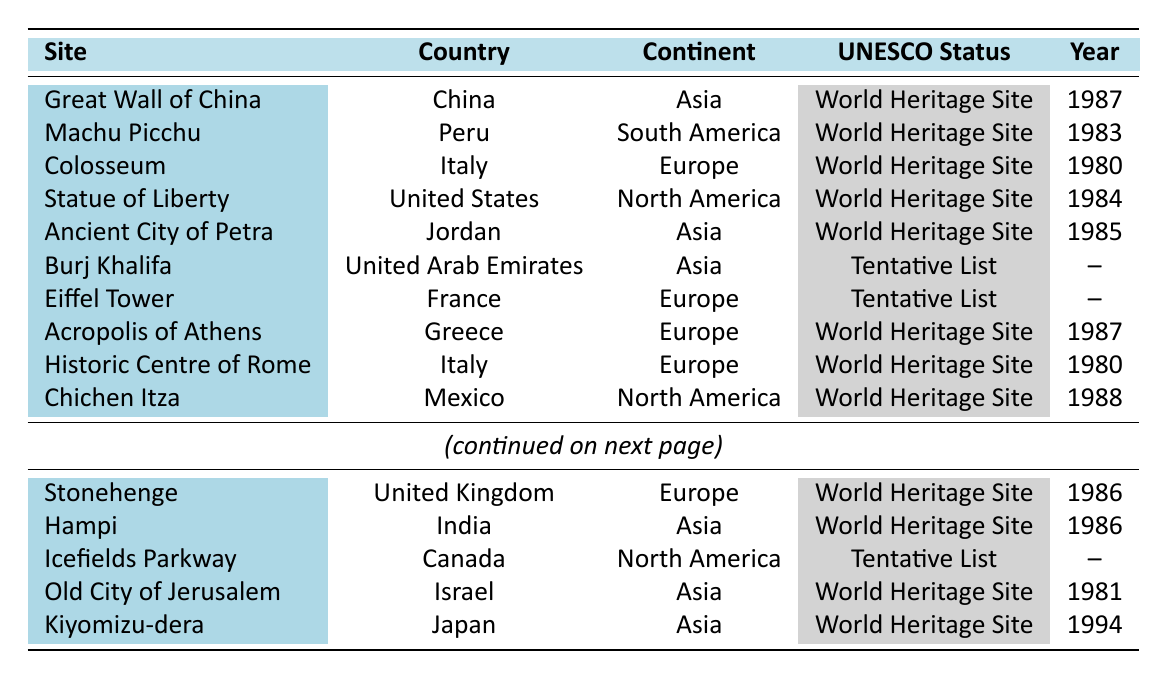What continent does the Great Wall of China belong to? The Great Wall of China is listed in the table and shows that its continent is Asia.
Answer: Asia Which site was inscribed as a UNESCO World Heritage Site in 1980? By reviewing the table, we can see both the Colosseum and the Historic Centre of Rome were inscribed in 1980.
Answer: Colosseum, Historic Centre of Rome How many sites on the list are located in North America? The table lists three sites in North America: Statue of Liberty, Chichen Itza, and Icefields Parkway.
Answer: 3 Is the Eiffel Tower a World Heritage Site? The Eiffel Tower is in the table and has the UNESCO status listed as "Tentative List," which means it is not yet a World Heritage Site.
Answer: No Which country has the site "Hampi"? The table indicates that Hampi is located in India.
Answer: India How many Asian sites are listed as World Heritage Sites? The Asian sites listed as World Heritage Sites in the table are the Great Wall of China, Ancient City of Petra, Hampi, Old City of Jerusalem, and Kiyomizu-dera, totaling five sites.
Answer: 5 Which site is the most recently inscribed on the UNESCO World Heritage list? The most recently inscribed site on the list is Kiyomizu-dera, which was inscribed in 1994, while other dates are earlier.
Answer: Kiyomizu-dera Compare the number of World Heritage Sites and Tentative List sites. How many more World Heritage Sites are there? There are 10 World Heritage Sites and 3 on the Tentative List in the table, resulting in 7 more World Heritage Sites (10 - 3 = 7).
Answer: 7 What year was the Statue of Liberty inscribed as a UNESCO site? The table shows that the Statue of Liberty was inscribed in 1984.
Answer: 1984 Which continent has the highest number of World Heritage Sites listed in the table? By counting the sites, Europe has the highest number, with 5 World Heritage Sites (Colosseum, Acropolis of Athens, Historic Centre of Rome, Stonehenge, and Eiffel Tower).
Answer: Europe 